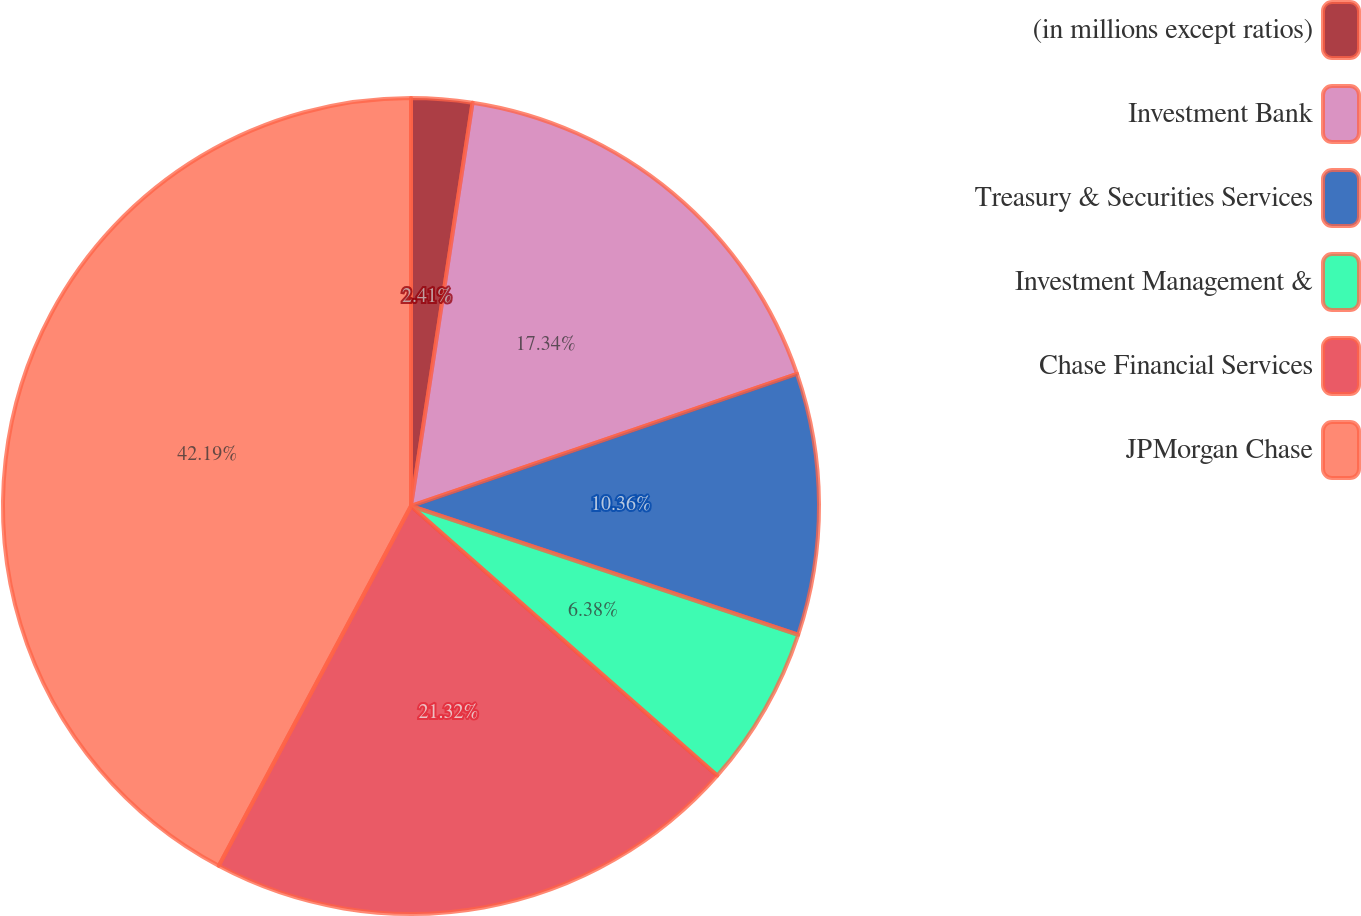Convert chart. <chart><loc_0><loc_0><loc_500><loc_500><pie_chart><fcel>(in millions except ratios)<fcel>Investment Bank<fcel>Treasury & Securities Services<fcel>Investment Management &<fcel>Chase Financial Services<fcel>JPMorgan Chase<nl><fcel>2.41%<fcel>17.34%<fcel>10.36%<fcel>6.38%<fcel>21.32%<fcel>42.19%<nl></chart> 